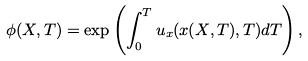<formula> <loc_0><loc_0><loc_500><loc_500>\phi ( X , T ) = \exp \left ( \int _ { 0 } ^ { T } u _ { x } ( x ( X , T ) , T ) d T \right ) ,</formula> 